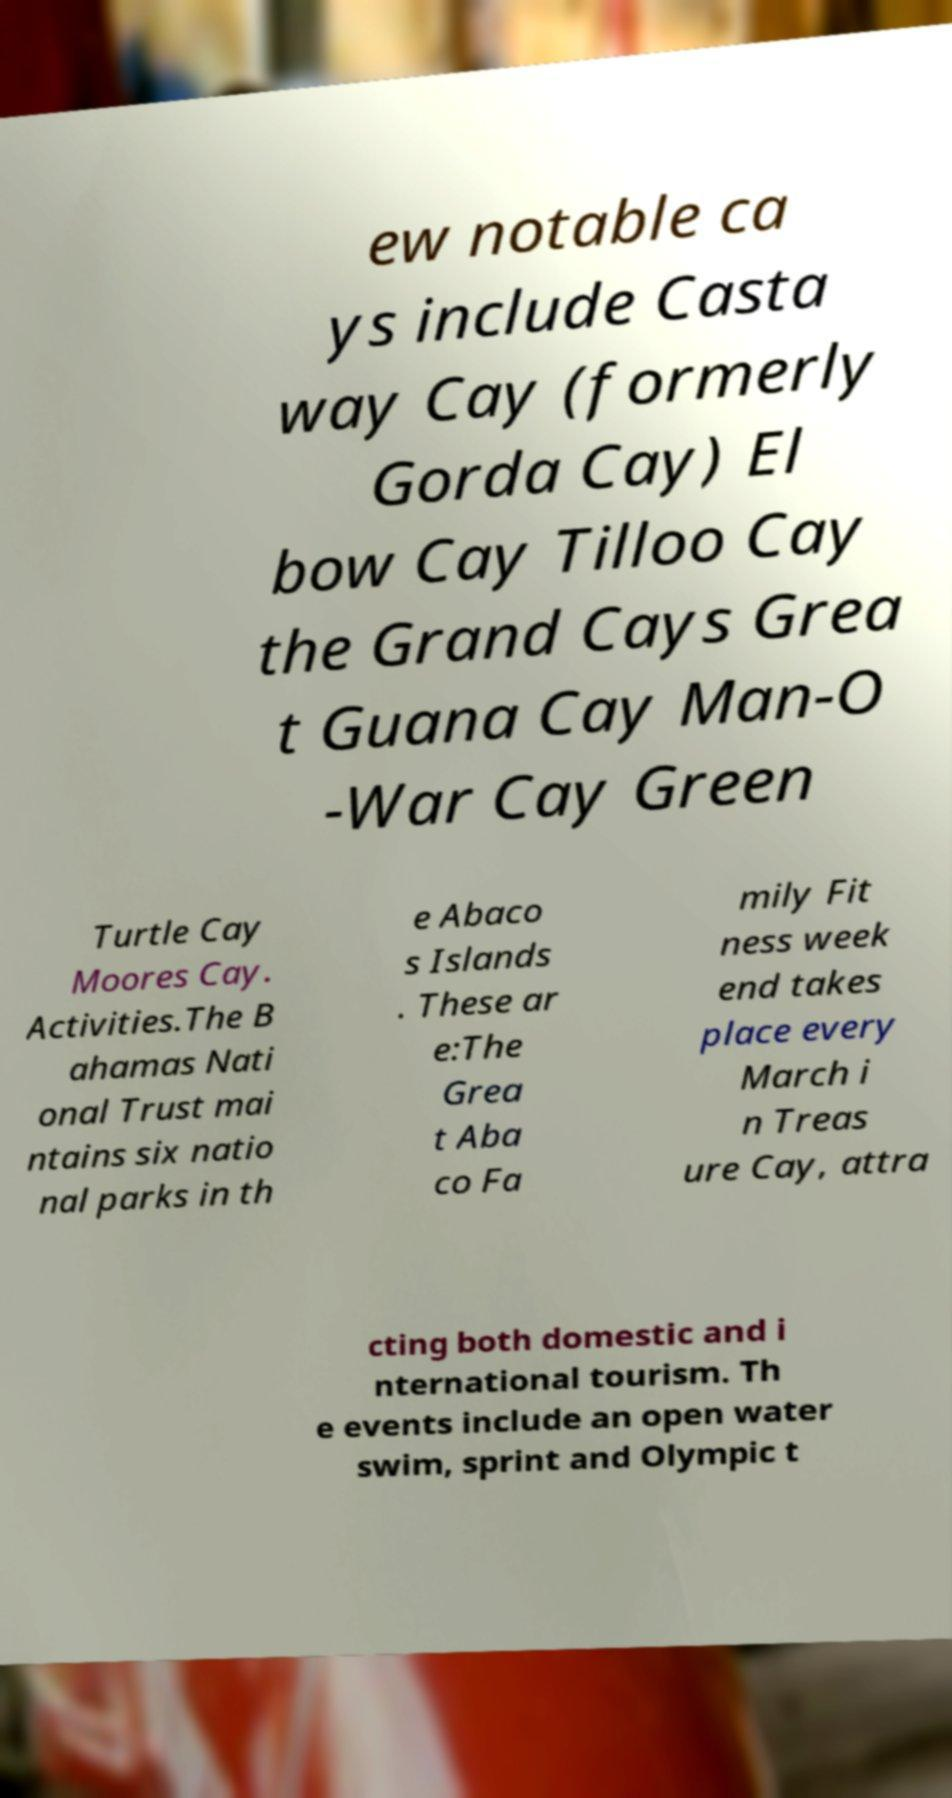What messages or text are displayed in this image? I need them in a readable, typed format. ew notable ca ys include Casta way Cay (formerly Gorda Cay) El bow Cay Tilloo Cay the Grand Cays Grea t Guana Cay Man-O -War Cay Green Turtle Cay Moores Cay. Activities.The B ahamas Nati onal Trust mai ntains six natio nal parks in th e Abaco s Islands . These ar e:The Grea t Aba co Fa mily Fit ness week end takes place every March i n Treas ure Cay, attra cting both domestic and i nternational tourism. Th e events include an open water swim, sprint and Olympic t 